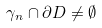Convert formula to latex. <formula><loc_0><loc_0><loc_500><loc_500>\gamma _ { n } \cap \partial D \neq \emptyset</formula> 